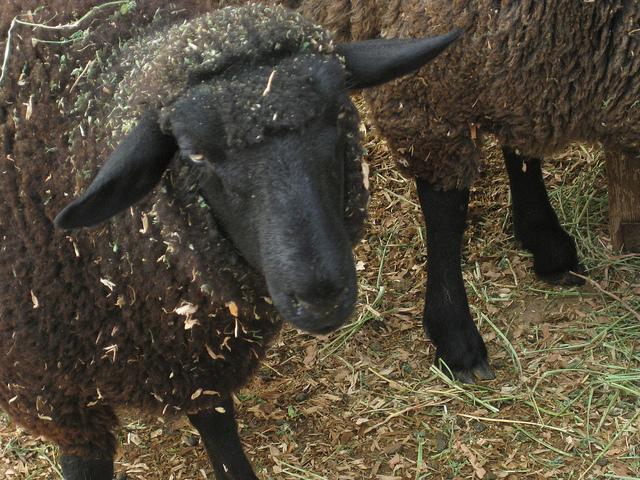How many sheep are visible?
Give a very brief answer. 2. How many people in the shot?
Give a very brief answer. 0. 